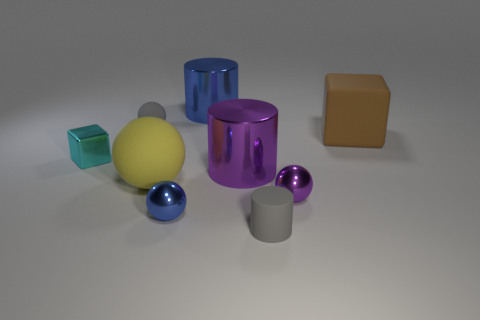How would you describe the lighting in this scene? The lighting in the scene casts soft shadows, indicating a diffuse light source, creating a muted and balanced illumination that accentuates the shapes and textures of the objects. 